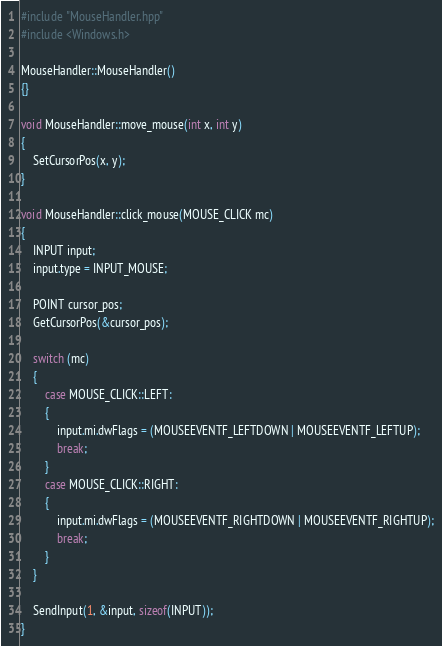<code> <loc_0><loc_0><loc_500><loc_500><_C++_>#include "MouseHandler.hpp"
#include <Windows.h>

MouseHandler::MouseHandler()
{}

void MouseHandler::move_mouse(int x, int y)
{
    SetCursorPos(x, y);
}

void MouseHandler::click_mouse(MOUSE_CLICK mc)
{
    INPUT input;
    input.type = INPUT_MOUSE;

    POINT cursor_pos;
    GetCursorPos(&cursor_pos);

    switch (mc)
    {
        case MOUSE_CLICK::LEFT:
        {
            input.mi.dwFlags = (MOUSEEVENTF_LEFTDOWN | MOUSEEVENTF_LEFTUP);
            break;
        }
        case MOUSE_CLICK::RIGHT:
        {
            input.mi.dwFlags = (MOUSEEVENTF_RIGHTDOWN | MOUSEEVENTF_RIGHTUP);
            break;
        }
    }

    SendInput(1, &input, sizeof(INPUT));
}
</code> 